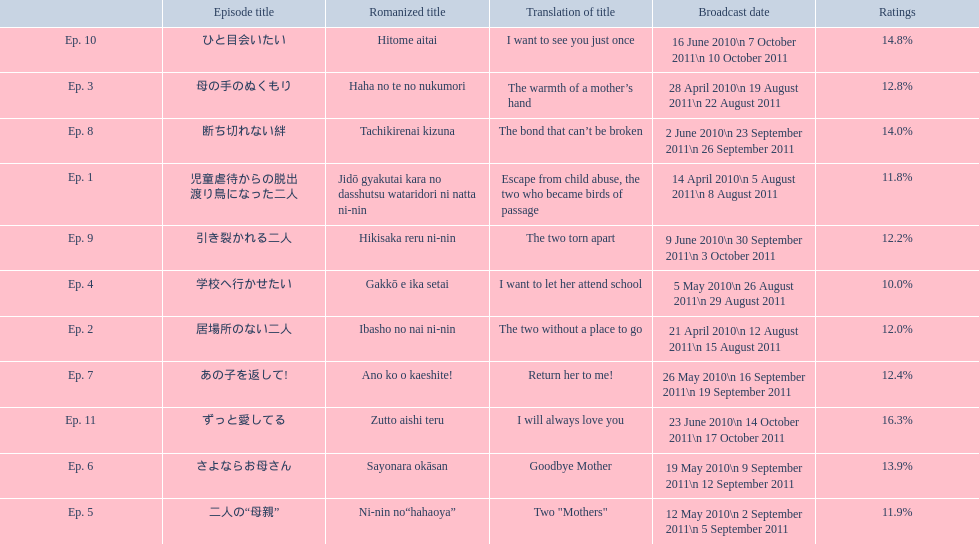What episode number was the only episode to have over 16% of ratings? 11. 